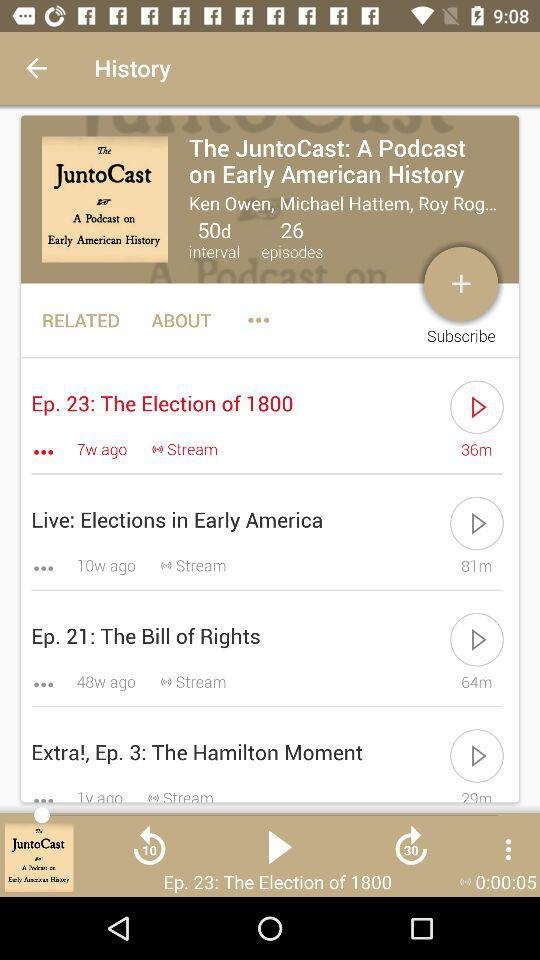How long ago did episode 23 come out? Episode 23 came out seven weeks ago. 